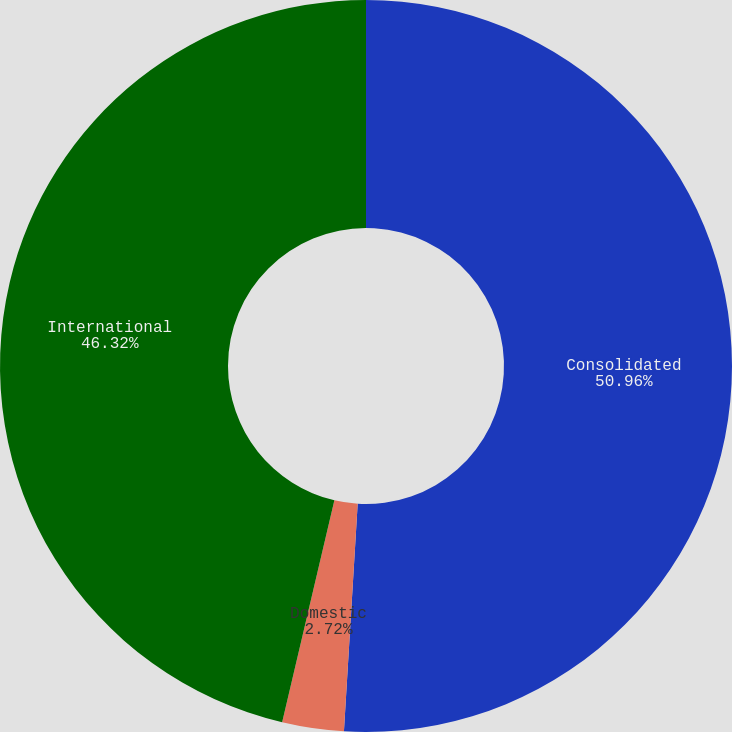Convert chart. <chart><loc_0><loc_0><loc_500><loc_500><pie_chart><fcel>Consolidated<fcel>Domestic<fcel>International<nl><fcel>50.96%<fcel>2.72%<fcel>46.32%<nl></chart> 